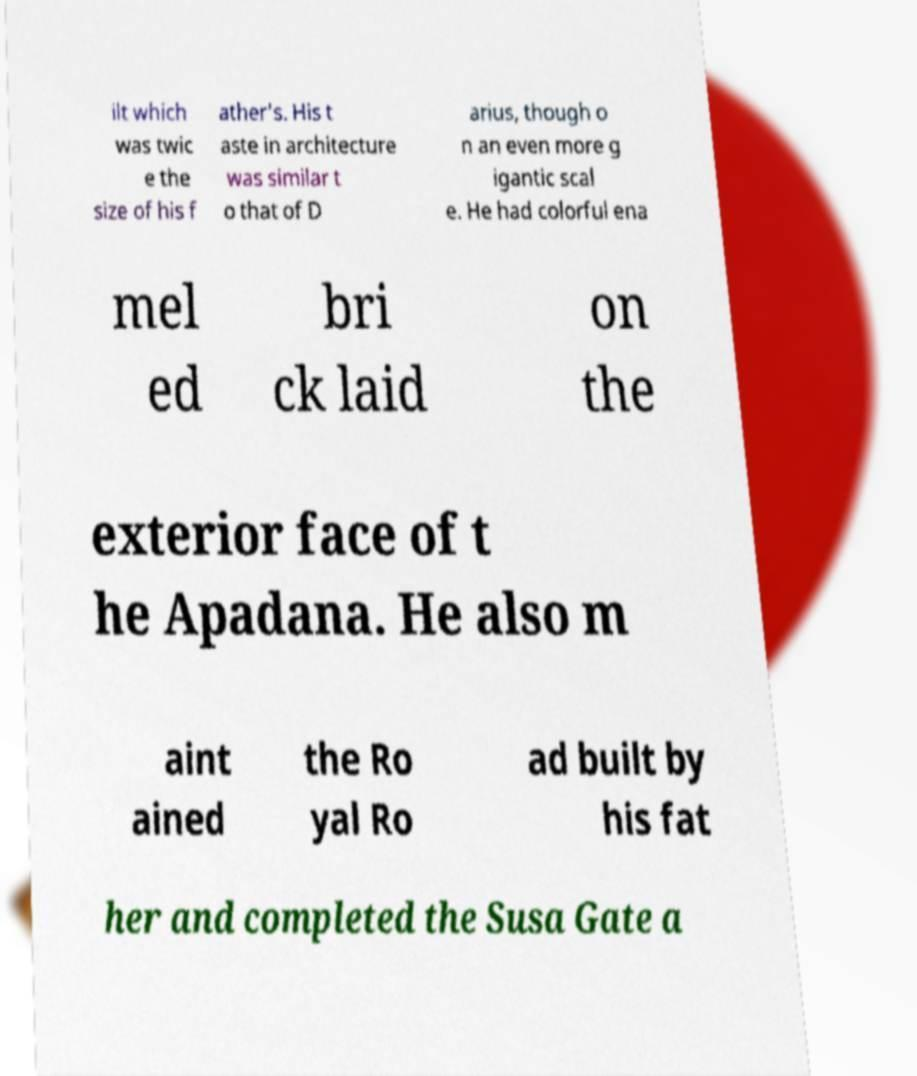Please read and relay the text visible in this image. What does it say? ilt which was twic e the size of his f ather's. His t aste in architecture was similar t o that of D arius, though o n an even more g igantic scal e. He had colorful ena mel ed bri ck laid on the exterior face of t he Apadana. He also m aint ained the Ro yal Ro ad built by his fat her and completed the Susa Gate a 